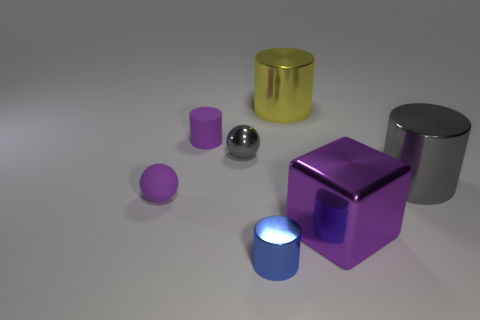Subtract 1 cylinders. How many cylinders are left? 3 Subtract all metal cylinders. How many cylinders are left? 1 Subtract all purple cylinders. How many cylinders are left? 3 Subtract all red cylinders. Subtract all blue spheres. How many cylinders are left? 4 Add 3 shiny cubes. How many objects exist? 10 Subtract all spheres. How many objects are left? 5 Add 4 yellow shiny objects. How many yellow shiny objects are left? 5 Add 7 brown shiny cylinders. How many brown shiny cylinders exist? 7 Subtract 1 gray balls. How many objects are left? 6 Subtract all blue shiny cylinders. Subtract all small gray metallic things. How many objects are left? 5 